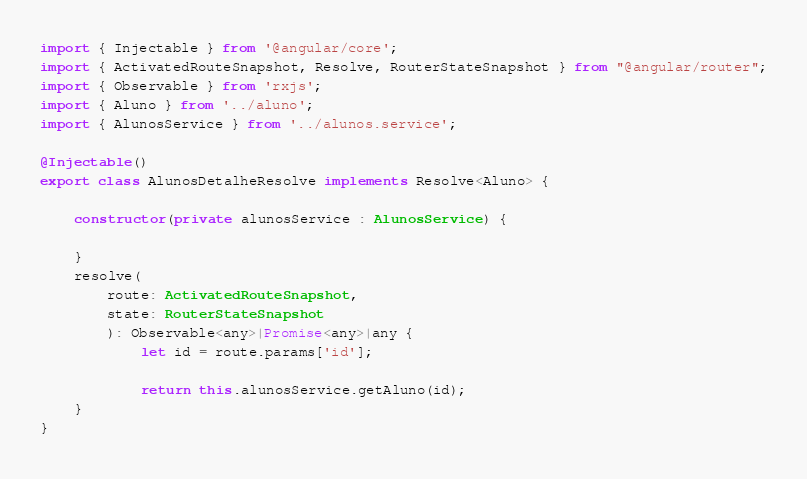<code> <loc_0><loc_0><loc_500><loc_500><_TypeScript_>import { Injectable } from '@angular/core';
import { ActivatedRouteSnapshot, Resolve, RouterStateSnapshot } from "@angular/router";
import { Observable } from 'rxjs';
import { Aluno } from '../aluno';
import { AlunosService } from '../alunos.service';

@Injectable()
export class AlunosDetalheResolve implements Resolve<Aluno> {
    
    constructor(private alunosService : AlunosService) {

    }
    resolve(
        route: ActivatedRouteSnapshot,
        state: RouterStateSnapshot
        ): Observable<any>|Promise<any>|any {
            let id = route.params['id'];
            
            return this.alunosService.getAluno(id);
    }
}</code> 